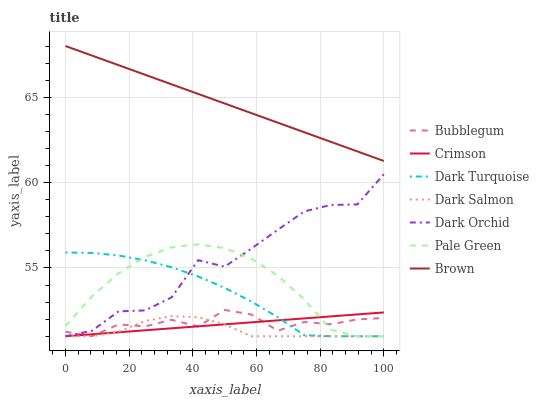Does Dark Salmon have the minimum area under the curve?
Answer yes or no. Yes. Does Brown have the maximum area under the curve?
Answer yes or no. Yes. Does Dark Turquoise have the minimum area under the curve?
Answer yes or no. No. Does Dark Turquoise have the maximum area under the curve?
Answer yes or no. No. Is Crimson the smoothest?
Answer yes or no. Yes. Is Dark Orchid the roughest?
Answer yes or no. Yes. Is Dark Turquoise the smoothest?
Answer yes or no. No. Is Dark Turquoise the roughest?
Answer yes or no. No. Does Dark Turquoise have the lowest value?
Answer yes or no. Yes. Does Brown have the highest value?
Answer yes or no. Yes. Does Dark Turquoise have the highest value?
Answer yes or no. No. Is Dark Salmon less than Brown?
Answer yes or no. Yes. Is Brown greater than Dark Turquoise?
Answer yes or no. Yes. Does Dark Turquoise intersect Dark Orchid?
Answer yes or no. Yes. Is Dark Turquoise less than Dark Orchid?
Answer yes or no. No. Is Dark Turquoise greater than Dark Orchid?
Answer yes or no. No. Does Dark Salmon intersect Brown?
Answer yes or no. No. 